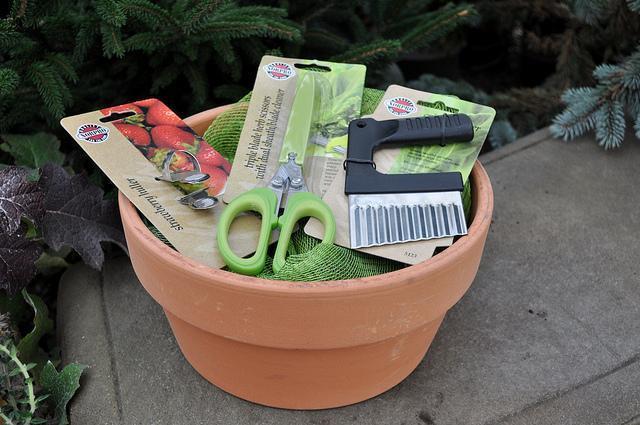How many scissors are there?
Give a very brief answer. 1. How many vases can you see?
Give a very brief answer. 1. 